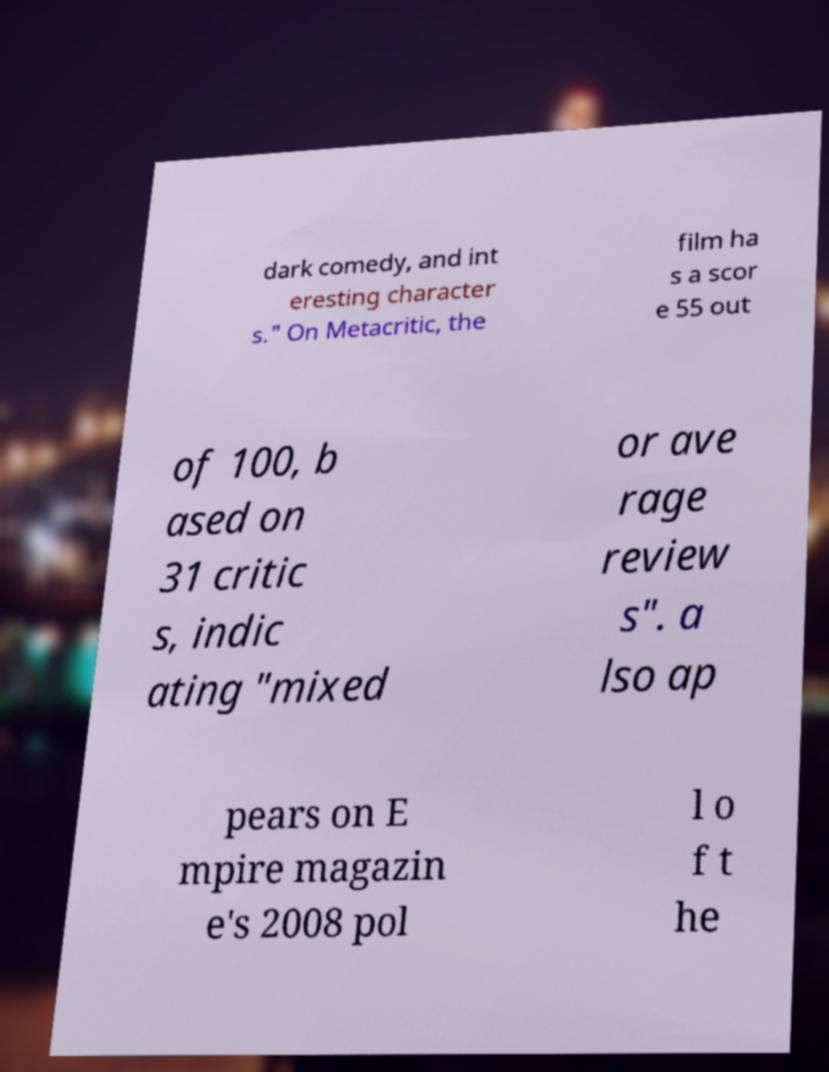For documentation purposes, I need the text within this image transcribed. Could you provide that? dark comedy, and int eresting character s." On Metacritic, the film ha s a scor e 55 out of 100, b ased on 31 critic s, indic ating "mixed or ave rage review s". a lso ap pears on E mpire magazin e's 2008 pol l o f t he 